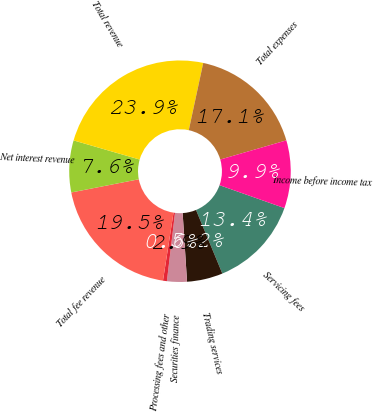Convert chart. <chart><loc_0><loc_0><loc_500><loc_500><pie_chart><fcel>Servicing fees<fcel>Trading services<fcel>Securities finance<fcel>Processing fees and other<fcel>Total fee revenue<fcel>Net interest revenue<fcel>Total revenue<fcel>Total expenses<fcel>Income before income tax<nl><fcel>13.35%<fcel>5.23%<fcel>2.9%<fcel>0.57%<fcel>19.47%<fcel>7.56%<fcel>23.88%<fcel>17.14%<fcel>9.89%<nl></chart> 